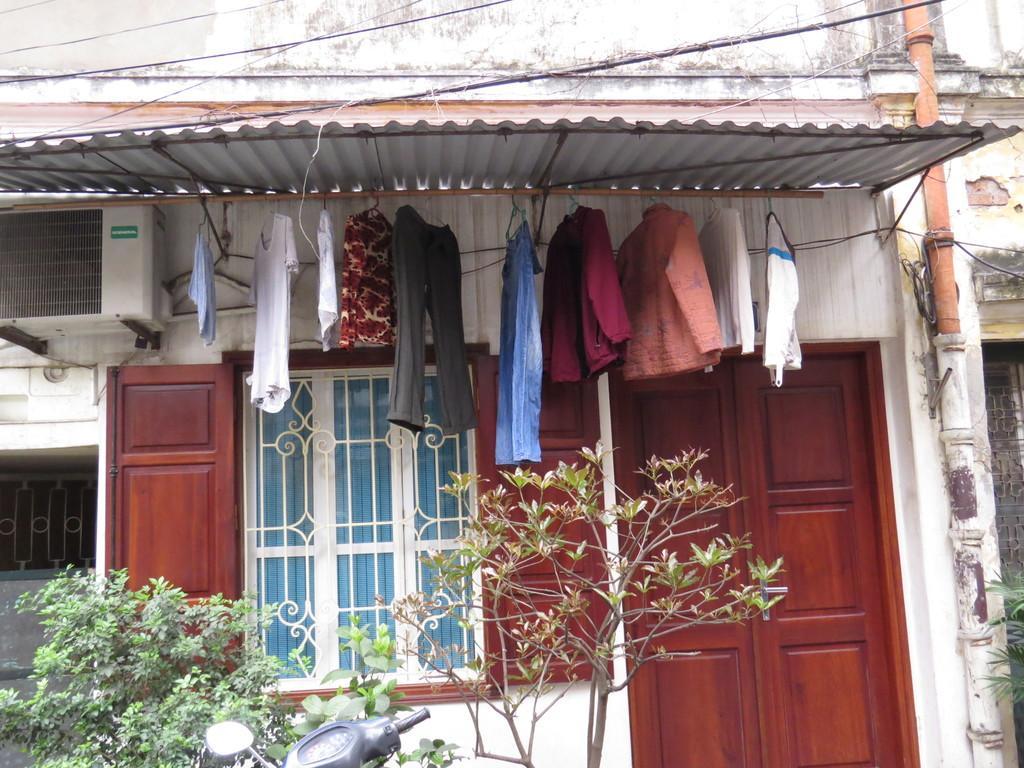In one or two sentences, can you explain what this image depicts? In this given picture, We can see a building, few clothes which are hanging to a wooden stick and attached to the shed after that, We can see an air conditioner, three trees which include with vehicle next, We can see a door, an electrical wire. 